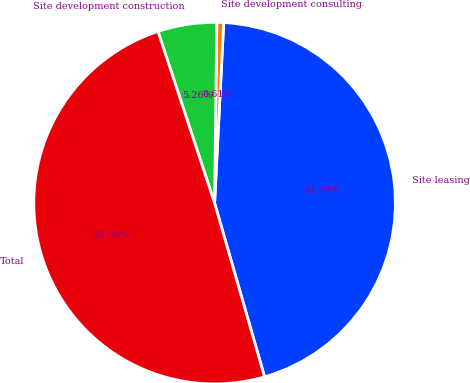Convert chart to OTSL. <chart><loc_0><loc_0><loc_500><loc_500><pie_chart><fcel>Site leasing<fcel>Site development consulting<fcel>Site development construction<fcel>Total<nl><fcel>44.74%<fcel>0.61%<fcel>5.26%<fcel>49.39%<nl></chart> 